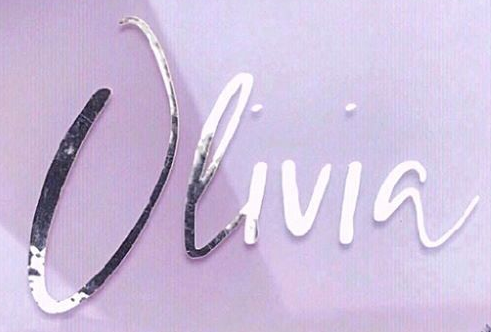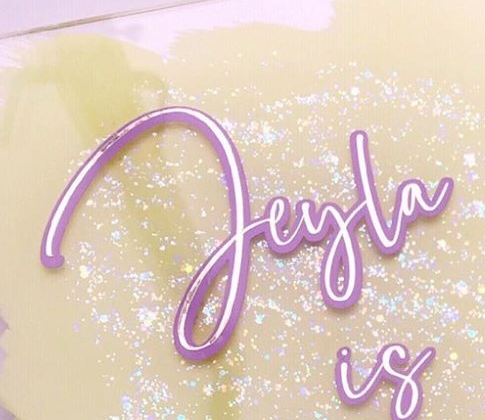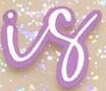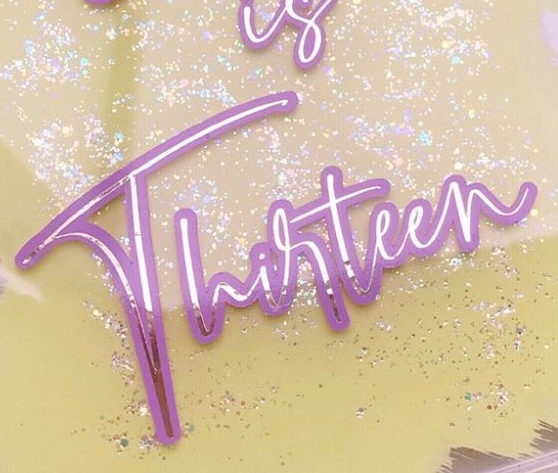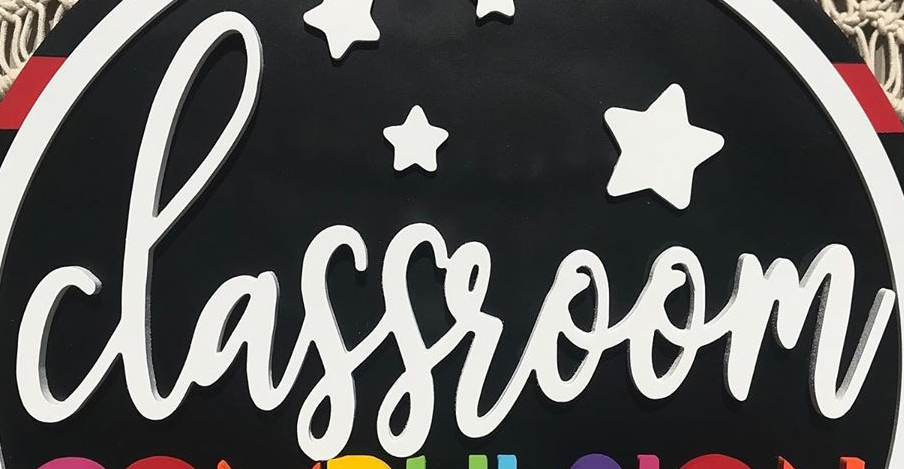Read the text content from these images in order, separated by a semicolon. Olivia; Jeyla; is; Thirteen; classroom 